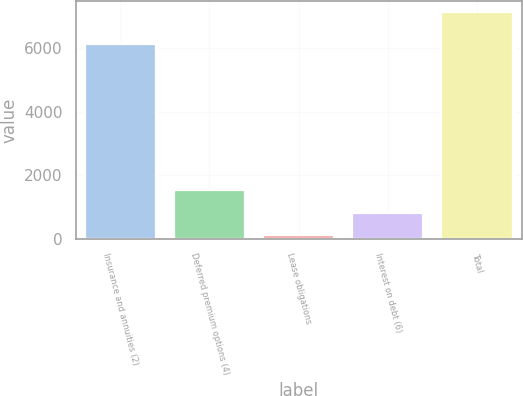<chart> <loc_0><loc_0><loc_500><loc_500><bar_chart><fcel>Insurance and annuities (2)<fcel>Deferred premium options (4)<fcel>Lease obligations<fcel>Interest on debt (6)<fcel>Total<nl><fcel>6138<fcel>1524.2<fcel>121<fcel>822.6<fcel>7137<nl></chart> 